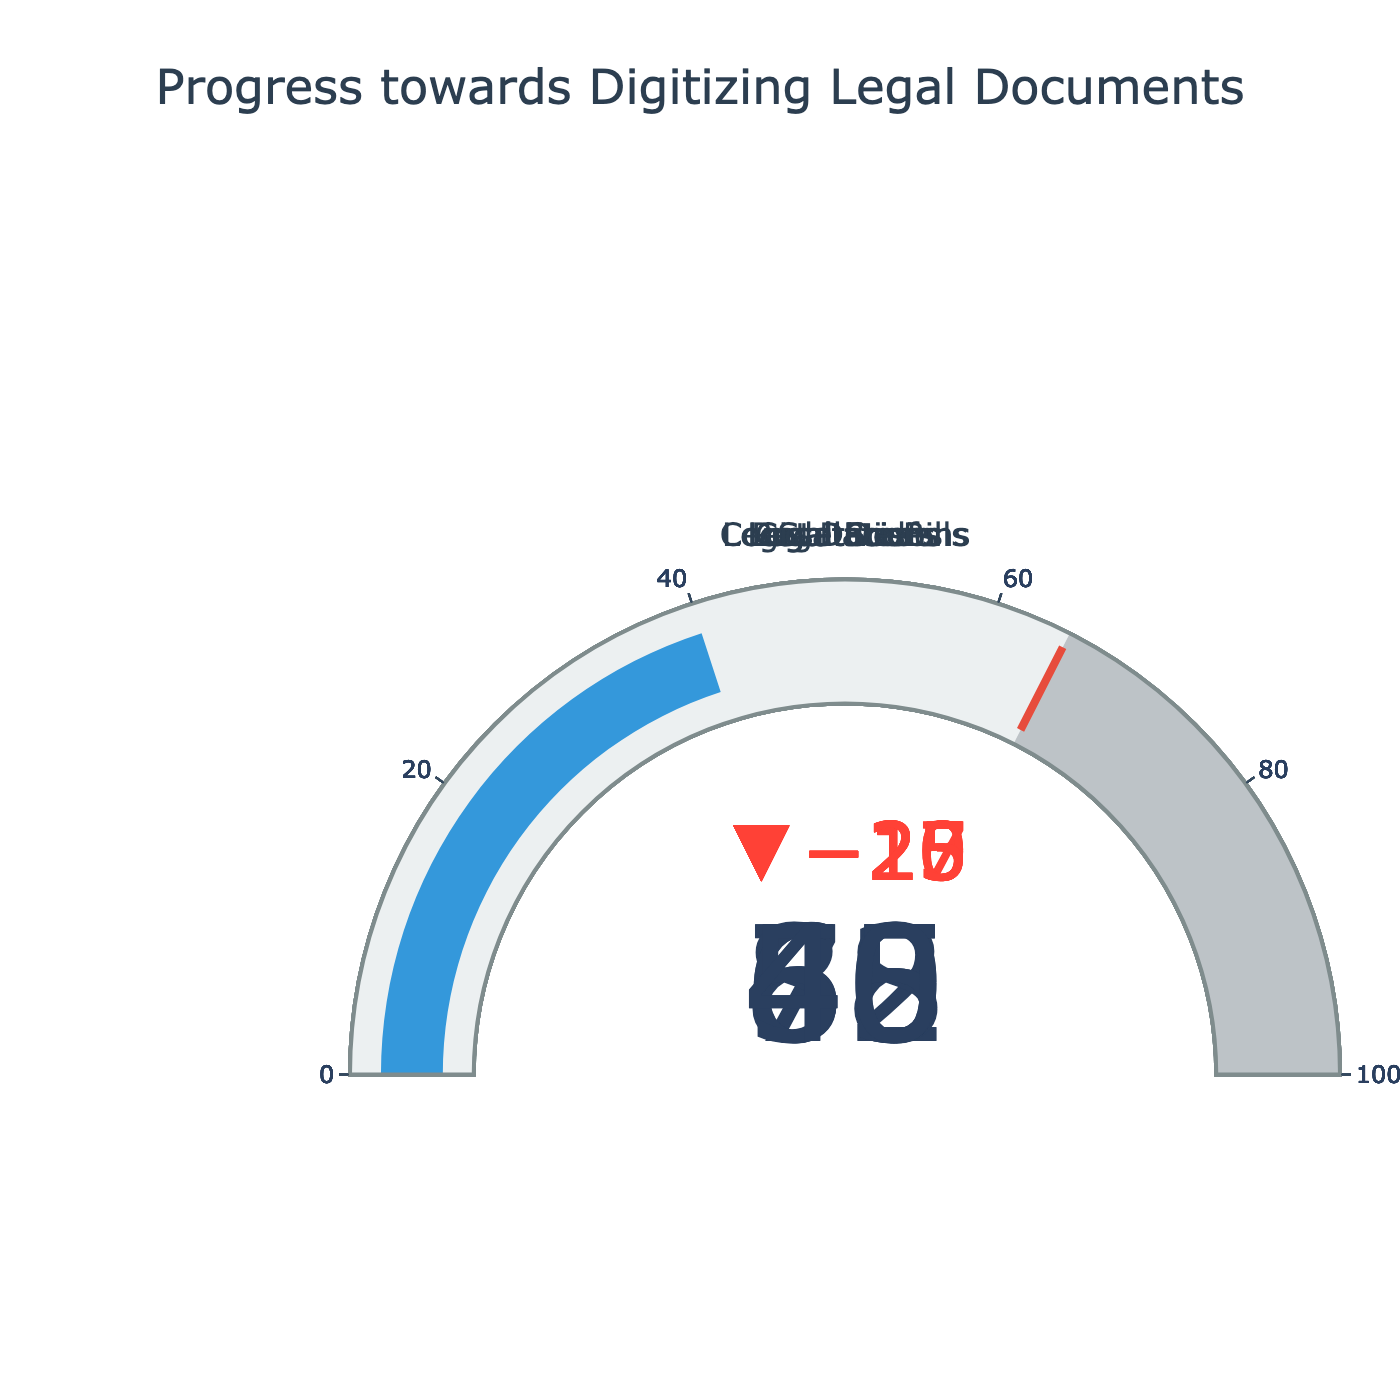what is the title of the figure? The title of the figure is located at the top and reads "Progress towards Digitizing Legal Documents".
Answer: Progress towards Digitizing Legal Documents How many different document types are displayed in the figure? By counting the distinct titles or labels within the figure, we see seven document types listed.
Answer: Seven Which document type has the lowest actual digitization progress? To find the lowest digitization progress, look at the 'Actual' values for all document types. Legislative Bills has the lowest, with an 'Actual' value of 40.
Answer: Legislative Bills What is the actual progress for Regulations compared to its target? The actual progress for Regulations is given as 60, and the target is 80.
Answer: 60 vs 80 What is the average target digitization percentage across all document types? First sum all target values: 90, 95, 85, 80, 70, 75, 65; Total is 560. Then divide by the number of document types, which is 7. So, 560/7 = 80.
Answer: 80 Which document type is closest to achieving its target digitization? To determine the closest, calculate the difference between 'Actual' and 'Target' for all document types. The smallest difference is for Court Decisions, with an 'Actual' of 75 and a 'Target' of 90 (Difference of 15).
Answer: Court Decisions How much more needs to be digitized for Legal Forms to reach its target? The target for Legal Forms is 75 and its actual progress is 55. Therefore, 75 - 55 = 20 more needs to be digitized.
Answer: 20 Between Statutes and Legal Codes, which one has achieved more of its target percentage-wise? Calculate the percentage of the target achieved for each. Statutes: (82/95)*100 ≈ 86.3%, Legal Codes: (68/85)*100 ≈ 80%. Therefore, Statutes have achieved more of their target.
Answer: Statutes What is the sum of the actual digitization progress for all document types? Sum the 'Actual' values: 75 + 82 + 68 + 60 + 45 + 55 + 40 = 425.
Answer: 425 Which document type has the largest difference between its actual progress and the range end value? Calculate the difference for each document type between 'Actual' and 'Range End': Court Decisions (25), Statutes (18), Legal Codes (32), Regulations (40), Case Briefs (55), Legal Forms (45), Legislative Bills (60). Case Briefs has the largest difference of 55.
Answer: Case Briefs 